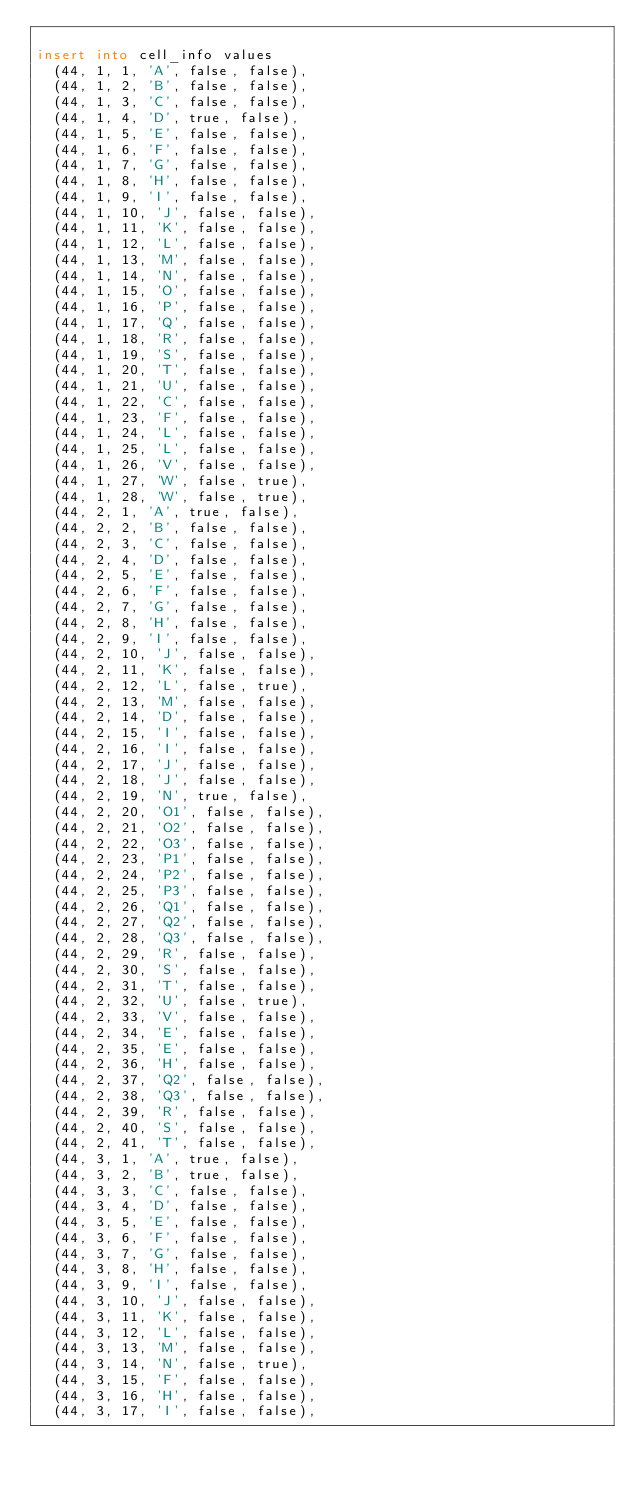Convert code to text. <code><loc_0><loc_0><loc_500><loc_500><_SQL_>
insert into cell_info values
  (44, 1, 1, 'A', false, false),
  (44, 1, 2, 'B', false, false),
  (44, 1, 3, 'C', false, false),
  (44, 1, 4, 'D', true, false),
  (44, 1, 5, 'E', false, false),
  (44, 1, 6, 'F', false, false),
  (44, 1, 7, 'G', false, false),
  (44, 1, 8, 'H', false, false),
  (44, 1, 9, 'I', false, false),
  (44, 1, 10, 'J', false, false),
  (44, 1, 11, 'K', false, false),
  (44, 1, 12, 'L', false, false),
  (44, 1, 13, 'M', false, false),
  (44, 1, 14, 'N', false, false),
  (44, 1, 15, 'O', false, false),
  (44, 1, 16, 'P', false, false),
  (44, 1, 17, 'Q', false, false),
  (44, 1, 18, 'R', false, false),
  (44, 1, 19, 'S', false, false),
  (44, 1, 20, 'T', false, false),
  (44, 1, 21, 'U', false, false),
  (44, 1, 22, 'C', false, false),
  (44, 1, 23, 'F', false, false),
  (44, 1, 24, 'L', false, false),
  (44, 1, 25, 'L', false, false),
  (44, 1, 26, 'V', false, false),
  (44, 1, 27, 'W', false, true),
  (44, 1, 28, 'W', false, true),
  (44, 2, 1, 'A', true, false),
  (44, 2, 2, 'B', false, false),
  (44, 2, 3, 'C', false, false),
  (44, 2, 4, 'D', false, false),
  (44, 2, 5, 'E', false, false),
  (44, 2, 6, 'F', false, false),
  (44, 2, 7, 'G', false, false),
  (44, 2, 8, 'H', false, false),
  (44, 2, 9, 'I', false, false),
  (44, 2, 10, 'J', false, false),
  (44, 2, 11, 'K', false, false),
  (44, 2, 12, 'L', false, true),
  (44, 2, 13, 'M', false, false),
  (44, 2, 14, 'D', false, false),
  (44, 2, 15, 'I', false, false),
  (44, 2, 16, 'I', false, false),
  (44, 2, 17, 'J', false, false),
  (44, 2, 18, 'J', false, false),
  (44, 2, 19, 'N', true, false),
  (44, 2, 20, 'O1', false, false),
  (44, 2, 21, 'O2', false, false),
  (44, 2, 22, 'O3', false, false),
  (44, 2, 23, 'P1', false, false),
  (44, 2, 24, 'P2', false, false),
  (44, 2, 25, 'P3', false, false),
  (44, 2, 26, 'Q1', false, false),
  (44, 2, 27, 'Q2', false, false),
  (44, 2, 28, 'Q3', false, false),
  (44, 2, 29, 'R', false, false),
  (44, 2, 30, 'S', false, false),
  (44, 2, 31, 'T', false, false),
  (44, 2, 32, 'U', false, true),
  (44, 2, 33, 'V', false, false),
  (44, 2, 34, 'E', false, false),
  (44, 2, 35, 'E', false, false),
  (44, 2, 36, 'H', false, false),
  (44, 2, 37, 'Q2', false, false),
  (44, 2, 38, 'Q3', false, false),
  (44, 2, 39, 'R', false, false),
  (44, 2, 40, 'S', false, false),
  (44, 2, 41, 'T', false, false),
  (44, 3, 1, 'A', true, false),
  (44, 3, 2, 'B', true, false),
  (44, 3, 3, 'C', false, false),
  (44, 3, 4, 'D', false, false),
  (44, 3, 5, 'E', false, false),
  (44, 3, 6, 'F', false, false),
  (44, 3, 7, 'G', false, false),
  (44, 3, 8, 'H', false, false),
  (44, 3, 9, 'I', false, false),
  (44, 3, 10, 'J', false, false),
  (44, 3, 11, 'K', false, false),
  (44, 3, 12, 'L', false, false),
  (44, 3, 13, 'M', false, false),
  (44, 3, 14, 'N', false, true),
  (44, 3, 15, 'F', false, false),
  (44, 3, 16, 'H', false, false),
  (44, 3, 17, 'I', false, false),</code> 